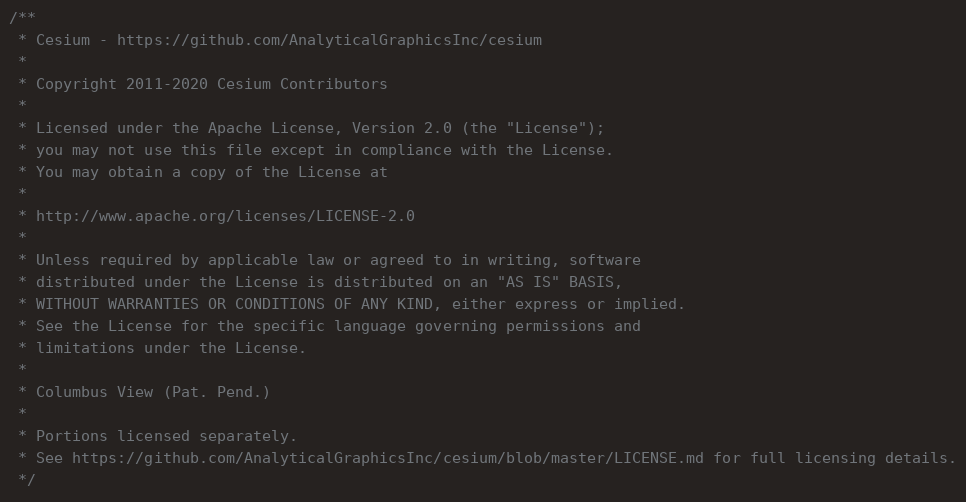<code> <loc_0><loc_0><loc_500><loc_500><_JavaScript_>/**
 * Cesium - https://github.com/AnalyticalGraphicsInc/cesium
 *
 * Copyright 2011-2020 Cesium Contributors
 *
 * Licensed under the Apache License, Version 2.0 (the "License");
 * you may not use this file except in compliance with the License.
 * You may obtain a copy of the License at
 *
 * http://www.apache.org/licenses/LICENSE-2.0
 *
 * Unless required by applicable law or agreed to in writing, software
 * distributed under the License is distributed on an "AS IS" BASIS,
 * WITHOUT WARRANTIES OR CONDITIONS OF ANY KIND, either express or implied.
 * See the License for the specific language governing permissions and
 * limitations under the License.
 *
 * Columbus View (Pat. Pend.)
 *
 * Portions licensed separately.
 * See https://github.com/AnalyticalGraphicsInc/cesium/blob/master/LICENSE.md for full licensing details.
 */</code> 